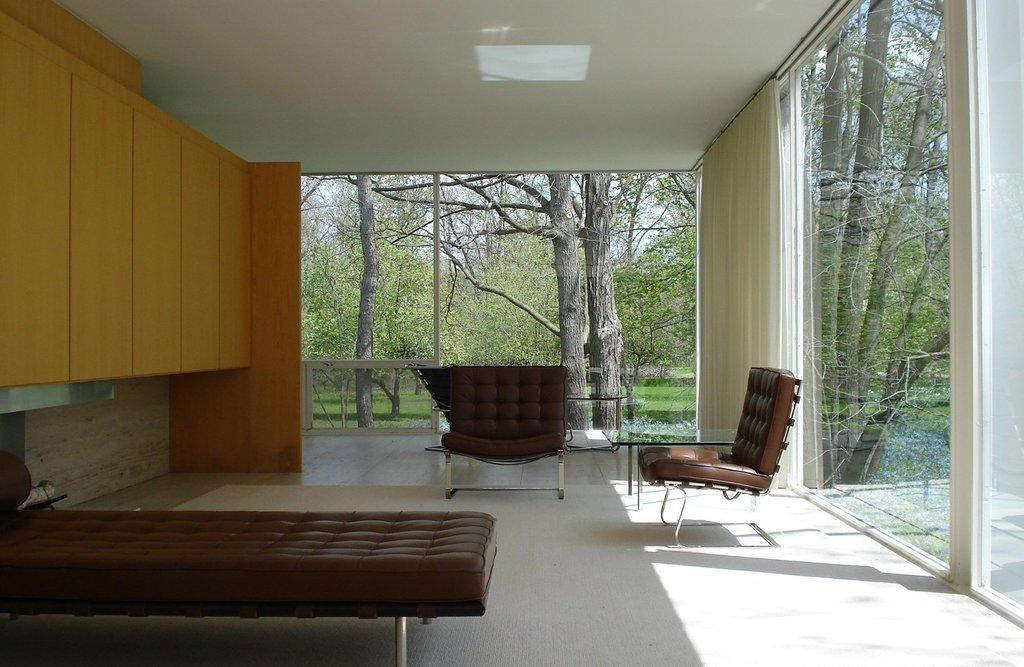What type of furniture is present in the image? There is a bed and two chairs in the image. What can be seen in the background of the image? Trees are visible in the background of the image. What type of birthday celebration is taking place in the image? There is no indication of a birthday celebration in the image. How are the chairs being used for play in the image? There is no indication of play or any activity involving the chairs in the image. 